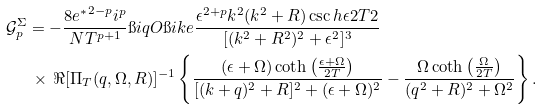Convert formula to latex. <formula><loc_0><loc_0><loc_500><loc_500>\mathcal { G } _ { p } ^ { \Sigma } & = - \frac { 8 { e ^ { * } } ^ { 2 - p } i ^ { p } } { N T ^ { p + 1 } } \i i q O \i i k e \frac { \epsilon ^ { 2 + p } k ^ { 2 } ( k ^ { 2 } + R ) \csc h { \epsilon } { 2 T } { 2 } } { [ ( k ^ { 2 } + R ^ { 2 } ) ^ { 2 } + \epsilon ^ { 2 } ] ^ { 3 } } \\ & \, \times \, \Re [ \Pi _ { T } ( q , \Omega , R ) ] ^ { - 1 } \left \{ \frac { ( \epsilon + \Omega ) \coth \left ( \frac { \epsilon + \Omega } { 2 T } \right ) } { [ ( k + q ) ^ { 2 } + R ] ^ { 2 } + ( \epsilon + \Omega ) ^ { 2 } } - \frac { \Omega \coth \left ( \frac { \Omega } { 2 T } \right ) } { ( q ^ { 2 } + R ) ^ { 2 } + \Omega ^ { 2 } } \right \} .</formula> 